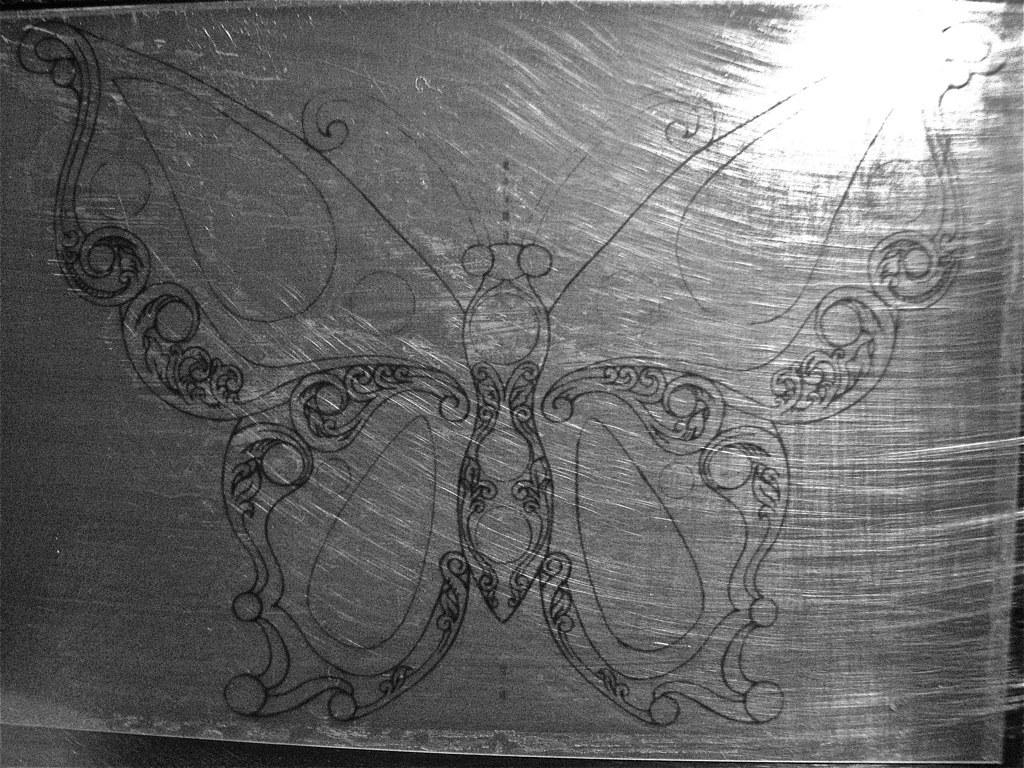What is the main subject of the image? The main subject of the image is a butterfly. How is the butterfly depicted in the image? The butterfly is drawn in the image. What type of instrument is the butterfly playing in the image? There is no instrument present in the image, and the butterfly is not playing any instrument. 